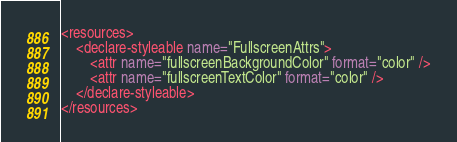Convert code to text. <code><loc_0><loc_0><loc_500><loc_500><_XML_><resources>
    <declare-styleable name="FullscreenAttrs">
        <attr name="fullscreenBackgroundColor" format="color" />
        <attr name="fullscreenTextColor" format="color" />
    </declare-styleable>
</resources></code> 